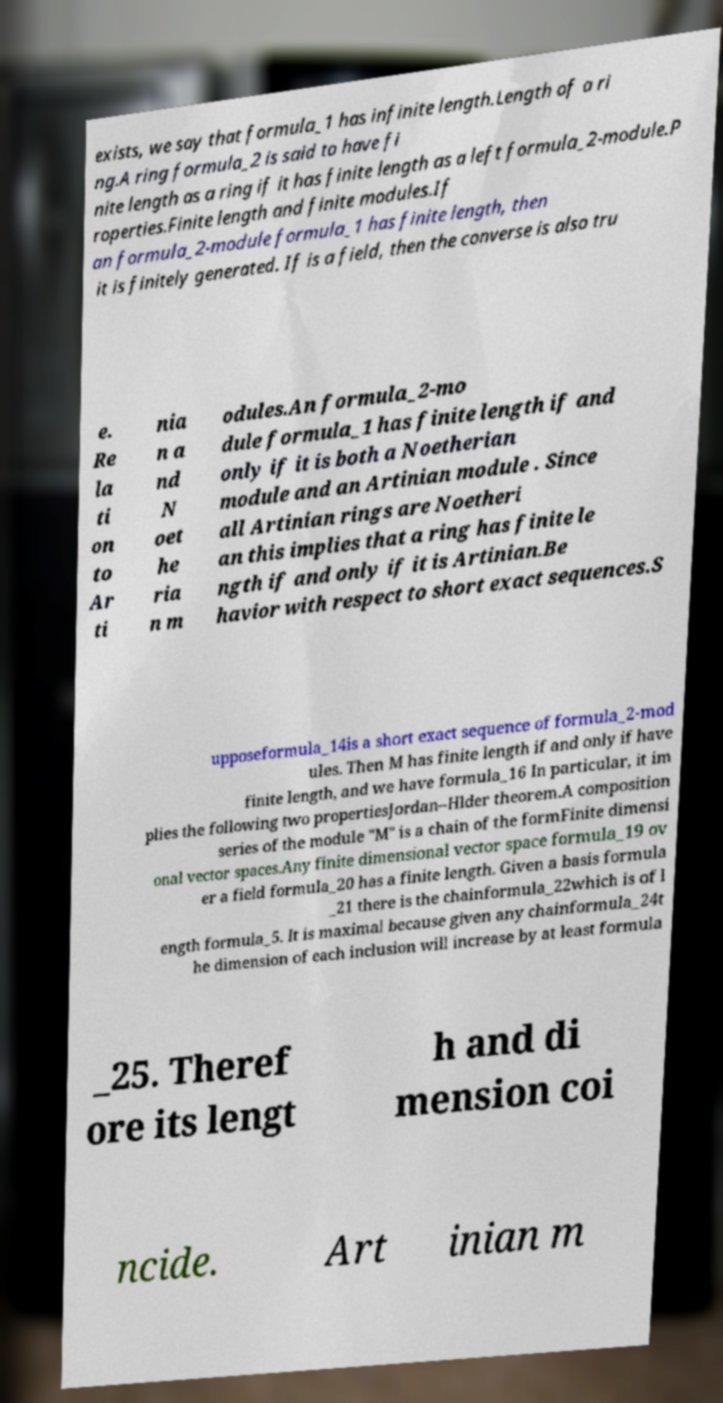Please read and relay the text visible in this image. What does it say? exists, we say that formula_1 has infinite length.Length of a ri ng.A ring formula_2 is said to have fi nite length as a ring if it has finite length as a left formula_2-module.P roperties.Finite length and finite modules.If an formula_2-module formula_1 has finite length, then it is finitely generated. If is a field, then the converse is also tru e. Re la ti on to Ar ti nia n a nd N oet he ria n m odules.An formula_2-mo dule formula_1 has finite length if and only if it is both a Noetherian module and an Artinian module . Since all Artinian rings are Noetheri an this implies that a ring has finite le ngth if and only if it is Artinian.Be havior with respect to short exact sequences.S upposeformula_14is a short exact sequence of formula_2-mod ules. Then M has finite length if and only if have finite length, and we have formula_16 In particular, it im plies the following two propertiesJordan–Hlder theorem.A composition series of the module "M" is a chain of the formFinite dimensi onal vector spaces.Any finite dimensional vector space formula_19 ov er a field formula_20 has a finite length. Given a basis formula _21 there is the chainformula_22which is of l ength formula_5. It is maximal because given any chainformula_24t he dimension of each inclusion will increase by at least formula _25. Theref ore its lengt h and di mension coi ncide. Art inian m 